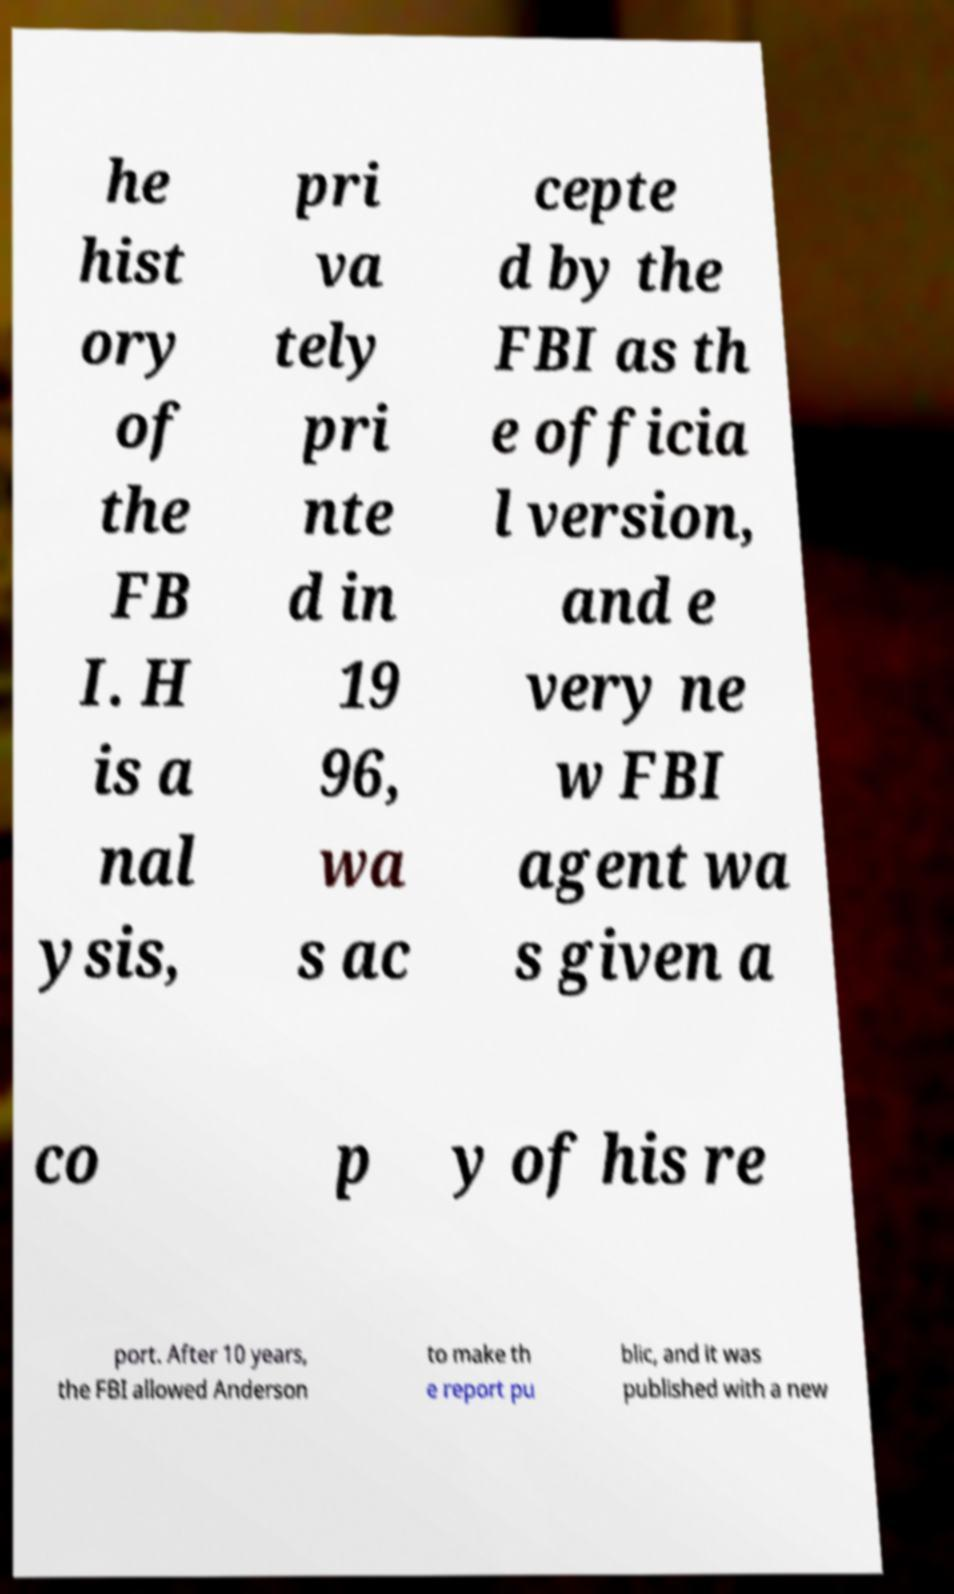What messages or text are displayed in this image? I need them in a readable, typed format. he hist ory of the FB I. H is a nal ysis, pri va tely pri nte d in 19 96, wa s ac cepte d by the FBI as th e officia l version, and e very ne w FBI agent wa s given a co p y of his re port. After 10 years, the FBI allowed Anderson to make th e report pu blic, and it was published with a new 